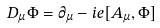Convert formula to latex. <formula><loc_0><loc_0><loc_500><loc_500>D _ { \mu } \Phi = \partial _ { \mu } - i e [ A _ { \mu } , \Phi ]</formula> 